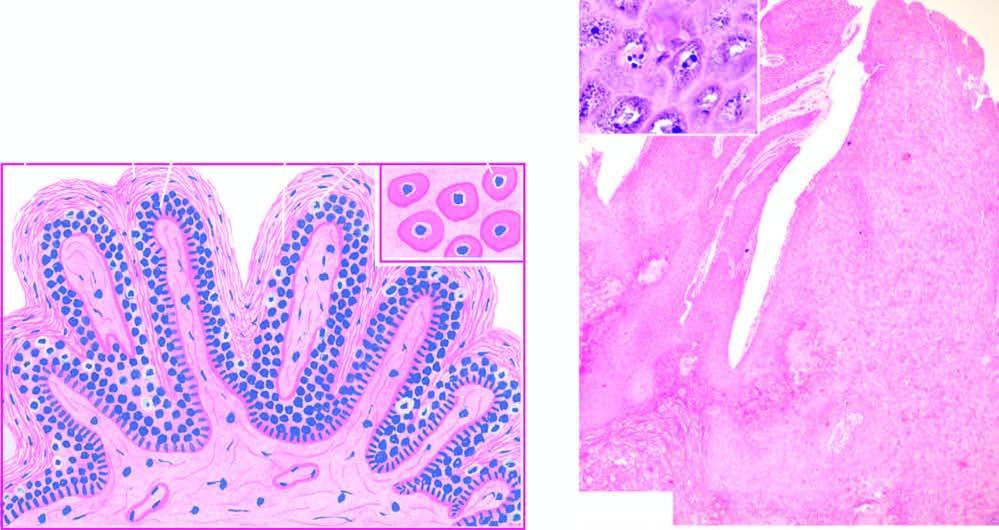where are foci of vacuolated cells found?
Answer the question using a single word or phrase. In the upper stratum malpighii 